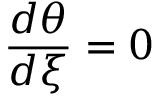Convert formula to latex. <formula><loc_0><loc_0><loc_500><loc_500>\frac { d \theta } { d \xi } = 0</formula> 